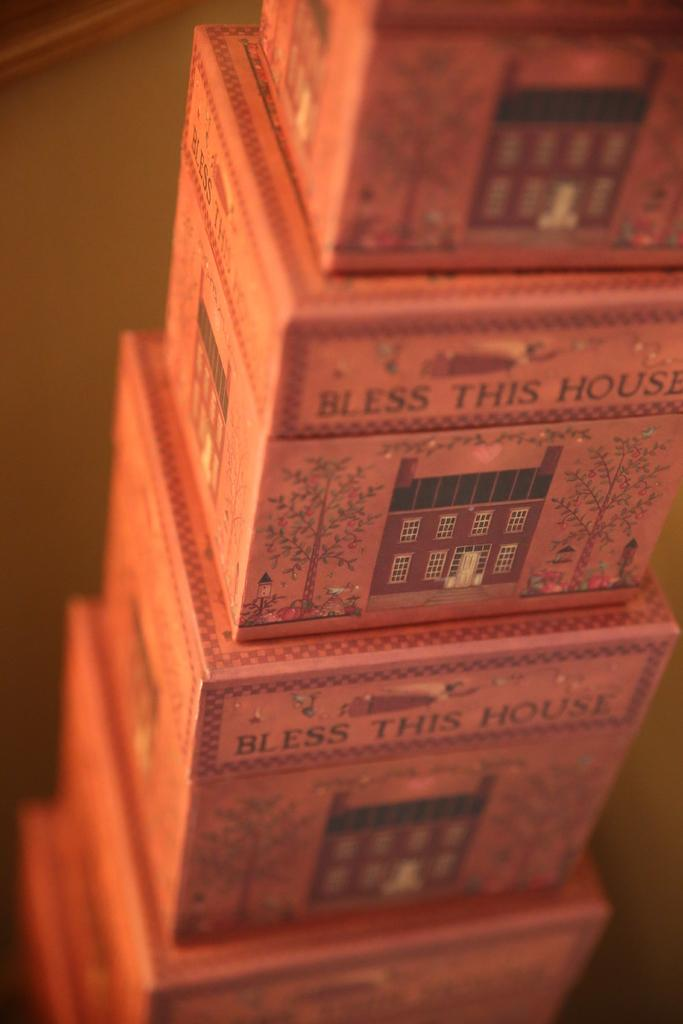<image>
Write a terse but informative summary of the picture. Many boxes that say "bless this house" are stacked on top of each other. 